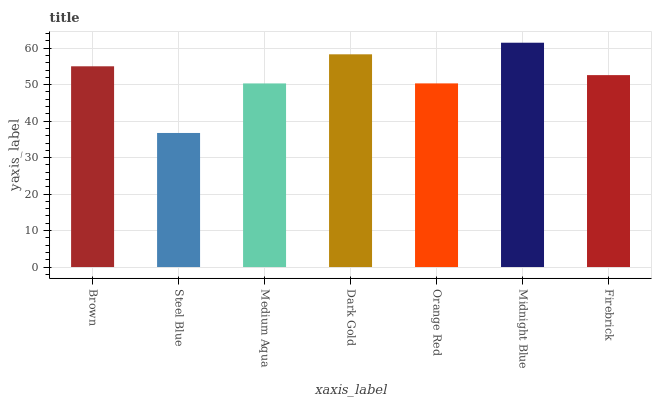Is Medium Aqua the minimum?
Answer yes or no. No. Is Medium Aqua the maximum?
Answer yes or no. No. Is Medium Aqua greater than Steel Blue?
Answer yes or no. Yes. Is Steel Blue less than Medium Aqua?
Answer yes or no. Yes. Is Steel Blue greater than Medium Aqua?
Answer yes or no. No. Is Medium Aqua less than Steel Blue?
Answer yes or no. No. Is Firebrick the high median?
Answer yes or no. Yes. Is Firebrick the low median?
Answer yes or no. Yes. Is Medium Aqua the high median?
Answer yes or no. No. Is Orange Red the low median?
Answer yes or no. No. 